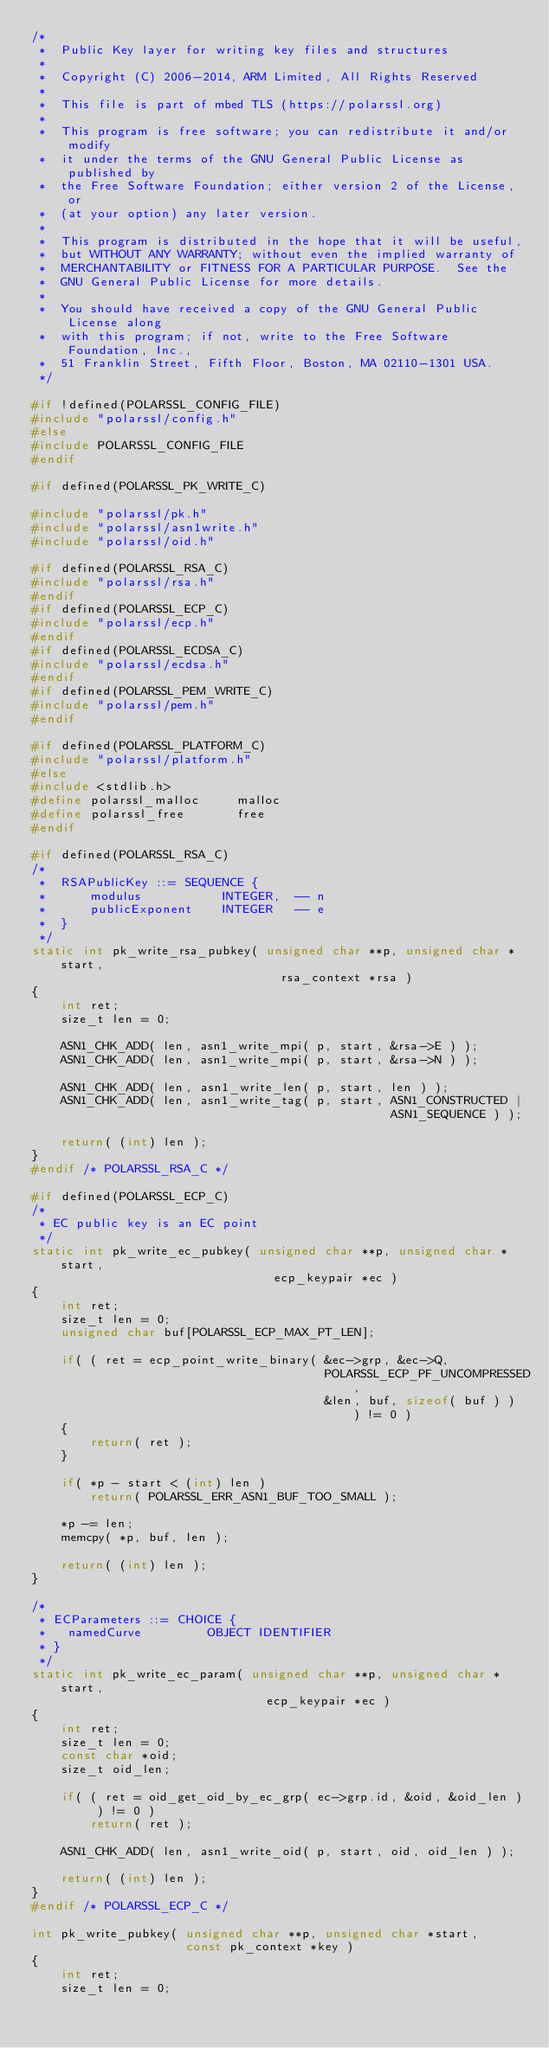Convert code to text. <code><loc_0><loc_0><loc_500><loc_500><_C_>/*
 *  Public Key layer for writing key files and structures
 *
 *  Copyright (C) 2006-2014, ARM Limited, All Rights Reserved
 *
 *  This file is part of mbed TLS (https://polarssl.org)
 *
 *  This program is free software; you can redistribute it and/or modify
 *  it under the terms of the GNU General Public License as published by
 *  the Free Software Foundation; either version 2 of the License, or
 *  (at your option) any later version.
 *
 *  This program is distributed in the hope that it will be useful,
 *  but WITHOUT ANY WARRANTY; without even the implied warranty of
 *  MERCHANTABILITY or FITNESS FOR A PARTICULAR PURPOSE.  See the
 *  GNU General Public License for more details.
 *
 *  You should have received a copy of the GNU General Public License along
 *  with this program; if not, write to the Free Software Foundation, Inc.,
 *  51 Franklin Street, Fifth Floor, Boston, MA 02110-1301 USA.
 */

#if !defined(POLARSSL_CONFIG_FILE)
#include "polarssl/config.h"
#else
#include POLARSSL_CONFIG_FILE
#endif

#if defined(POLARSSL_PK_WRITE_C)

#include "polarssl/pk.h"
#include "polarssl/asn1write.h"
#include "polarssl/oid.h"

#if defined(POLARSSL_RSA_C)
#include "polarssl/rsa.h"
#endif
#if defined(POLARSSL_ECP_C)
#include "polarssl/ecp.h"
#endif
#if defined(POLARSSL_ECDSA_C)
#include "polarssl/ecdsa.h"
#endif
#if defined(POLARSSL_PEM_WRITE_C)
#include "polarssl/pem.h"
#endif

#if defined(POLARSSL_PLATFORM_C)
#include "polarssl/platform.h"
#else
#include <stdlib.h>
#define polarssl_malloc     malloc
#define polarssl_free       free
#endif

#if defined(POLARSSL_RSA_C)
/*
 *  RSAPublicKey ::= SEQUENCE {
 *      modulus           INTEGER,  -- n
 *      publicExponent    INTEGER   -- e
 *  }
 */
static int pk_write_rsa_pubkey( unsigned char **p, unsigned char *start,
                                  rsa_context *rsa )
{
    int ret;
    size_t len = 0;

    ASN1_CHK_ADD( len, asn1_write_mpi( p, start, &rsa->E ) );
    ASN1_CHK_ADD( len, asn1_write_mpi( p, start, &rsa->N ) );

    ASN1_CHK_ADD( len, asn1_write_len( p, start, len ) );
    ASN1_CHK_ADD( len, asn1_write_tag( p, start, ASN1_CONSTRUCTED |
                                                 ASN1_SEQUENCE ) );

    return( (int) len );
}
#endif /* POLARSSL_RSA_C */

#if defined(POLARSSL_ECP_C)
/*
 * EC public key is an EC point
 */
static int pk_write_ec_pubkey( unsigned char **p, unsigned char *start,
                                 ecp_keypair *ec )
{
    int ret;
    size_t len = 0;
    unsigned char buf[POLARSSL_ECP_MAX_PT_LEN];

    if( ( ret = ecp_point_write_binary( &ec->grp, &ec->Q,
                                        POLARSSL_ECP_PF_UNCOMPRESSED,
                                        &len, buf, sizeof( buf ) ) ) != 0 )
    {
        return( ret );
    }

    if( *p - start < (int) len )
        return( POLARSSL_ERR_ASN1_BUF_TOO_SMALL );

    *p -= len;
    memcpy( *p, buf, len );

    return( (int) len );
}

/*
 * ECParameters ::= CHOICE {
 *   namedCurve         OBJECT IDENTIFIER
 * }
 */
static int pk_write_ec_param( unsigned char **p, unsigned char *start,
                                ecp_keypair *ec )
{
    int ret;
    size_t len = 0;
    const char *oid;
    size_t oid_len;

    if( ( ret = oid_get_oid_by_ec_grp( ec->grp.id, &oid, &oid_len ) ) != 0 )
        return( ret );

    ASN1_CHK_ADD( len, asn1_write_oid( p, start, oid, oid_len ) );

    return( (int) len );
}
#endif /* POLARSSL_ECP_C */

int pk_write_pubkey( unsigned char **p, unsigned char *start,
                     const pk_context *key )
{
    int ret;
    size_t len = 0;
</code> 